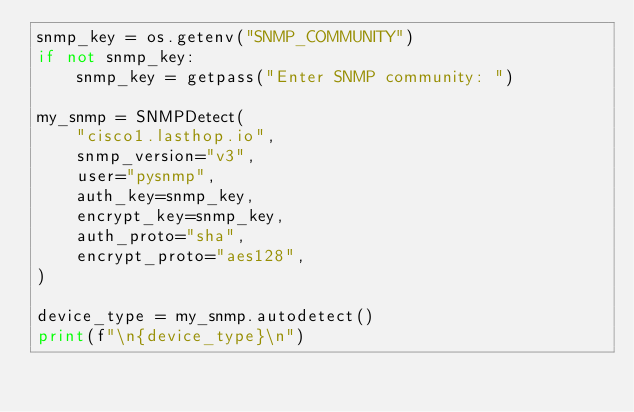<code> <loc_0><loc_0><loc_500><loc_500><_Python_>snmp_key = os.getenv("SNMP_COMMUNITY")
if not snmp_key:
    snmp_key = getpass("Enter SNMP community: ")

my_snmp = SNMPDetect(
    "cisco1.lasthop.io",
    snmp_version="v3",
    user="pysnmp",
    auth_key=snmp_key,
    encrypt_key=snmp_key,
    auth_proto="sha",
    encrypt_proto="aes128",
)

device_type = my_snmp.autodetect()
print(f"\n{device_type}\n")
</code> 